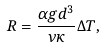Convert formula to latex. <formula><loc_0><loc_0><loc_500><loc_500>R = \frac { \alpha g d ^ { 3 } } { \nu \kappa } \Delta T ,</formula> 